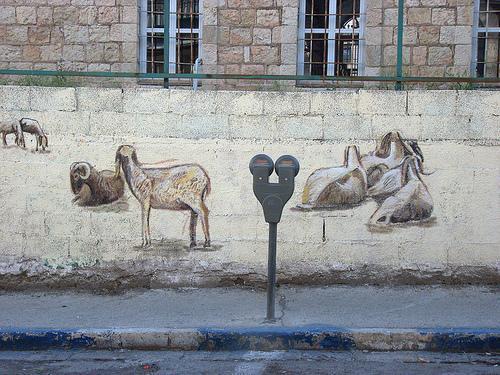How many meters are shown?
Give a very brief answer. 2. How many animals in the drawing are completely brown colored?
Give a very brief answer. 1. 